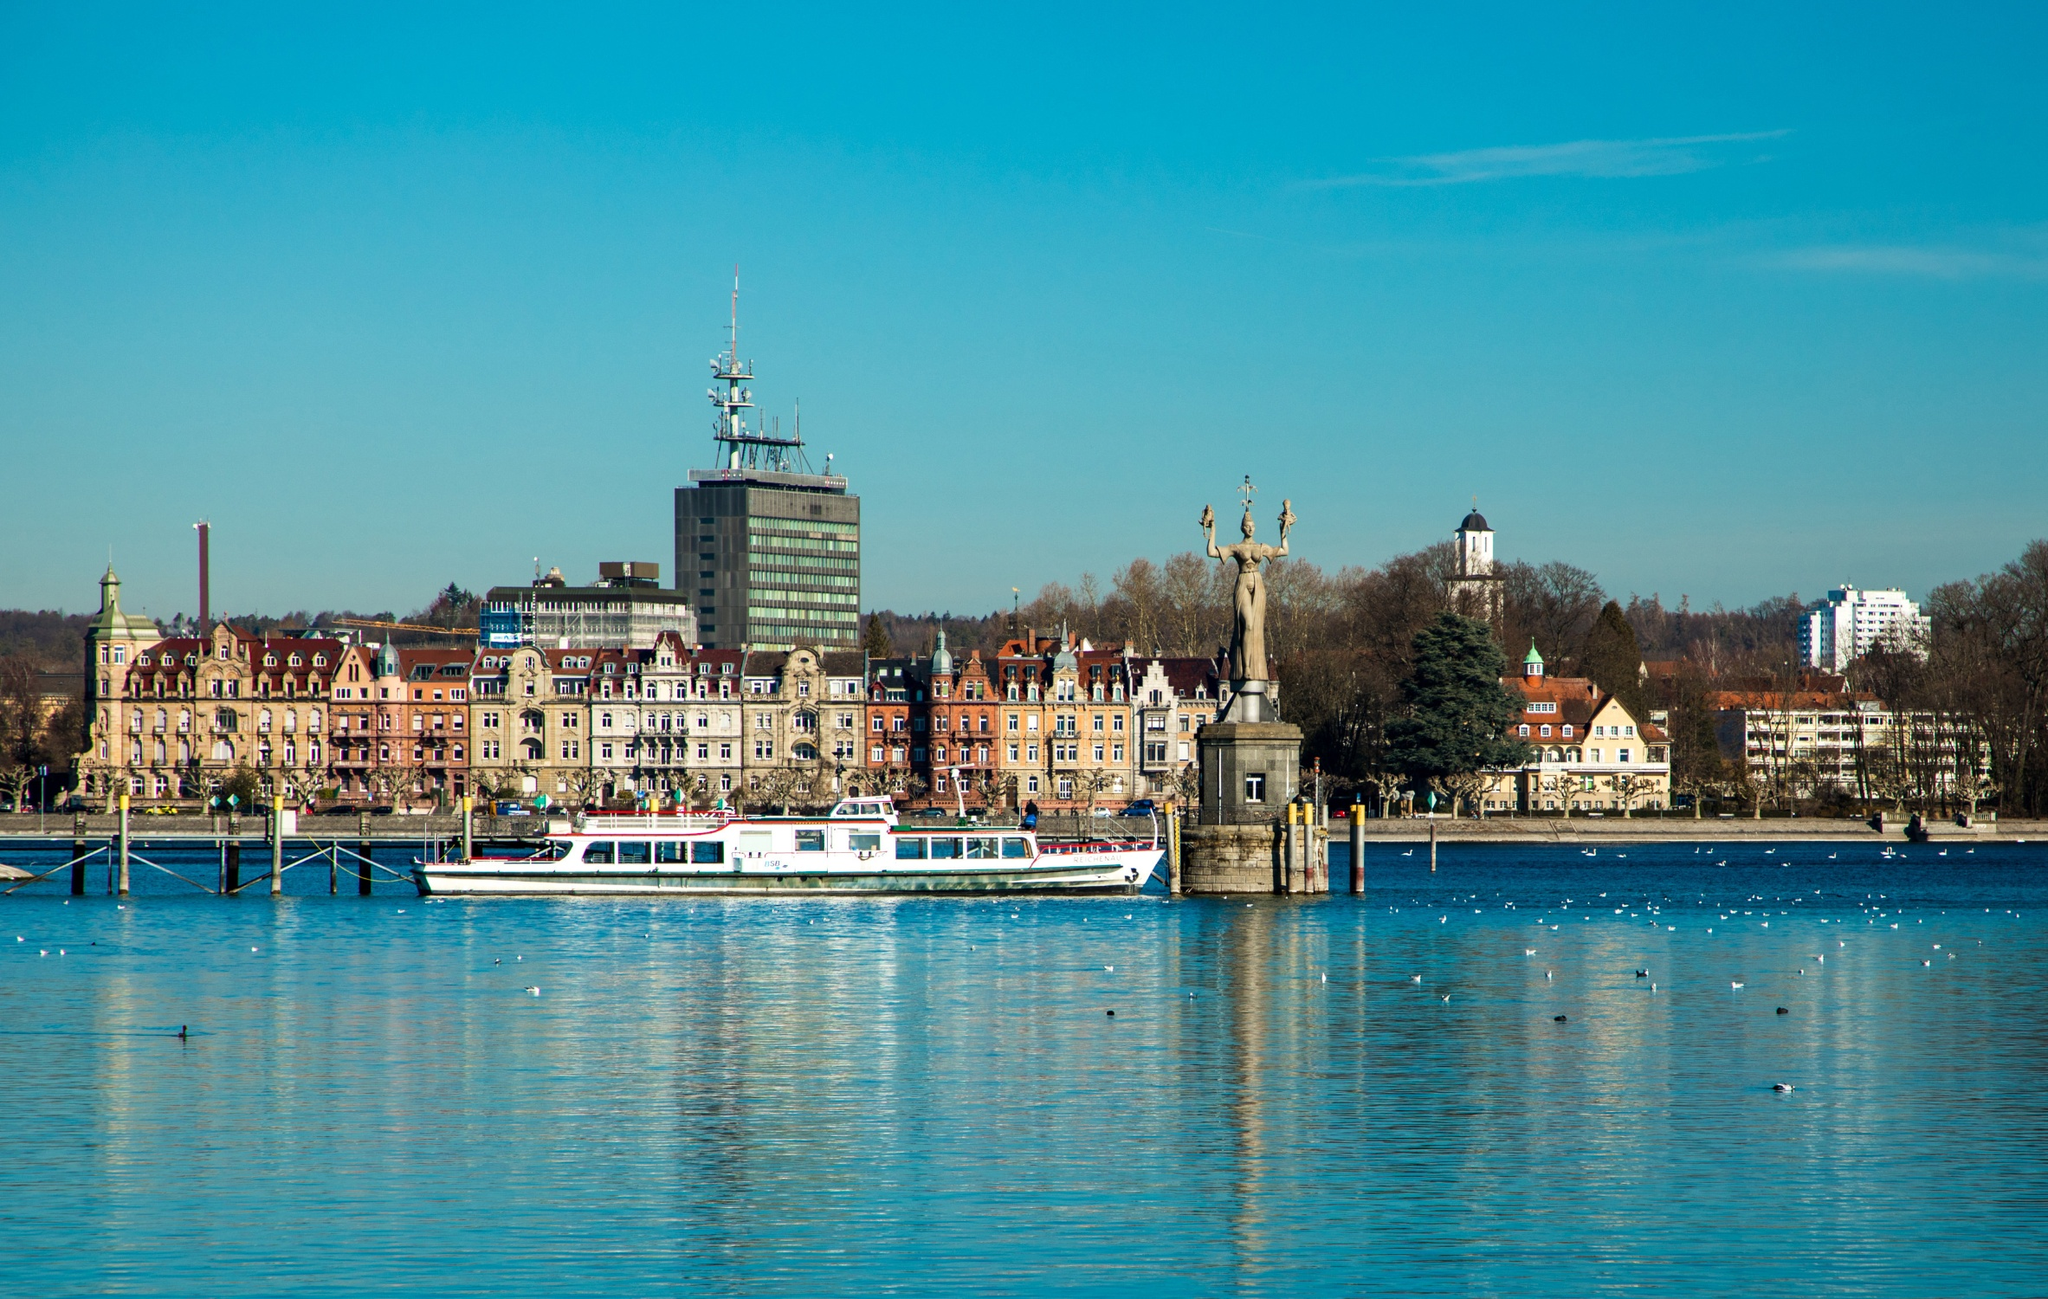Imagine an alternate universe where the city in the image is a famous setting for a mystery novel. What would the plot be? In an alternate universe, Constance Harbour is the eerie setting for the gripping mystery novel 'Shadows Over Constance'. The plot follows the talented but troubled detective, Clara Moreau, who is called to investigate an enigmatic series of disappearances tied to an ancient secret hidden within the foundation of the Imperia statue. As she delves deeper, Clara uncovers cryptic messages carved into the statue’s pedestal, revealing a clandestine society that has manipulated events in Constance for centuries. Tensions rise as Clara's pursuit of truth leads her to decrypt hidden symbols in the historic buildings and confront sinister figures in power, all while battling her own haunting past. The novel culminates in a thrilling confrontation on a stormy night at the harbour, where Clara confronts the mastermind behind the mystery, forcing her to make a fateful decision that will alter the town’s destiny forever. 